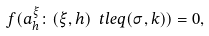Convert formula to latex. <formula><loc_0><loc_0><loc_500><loc_500>f ( a _ { h } ^ { \xi } \colon ( \xi , h ) \ t l e q ( \sigma , k ) ) = 0 ,</formula> 